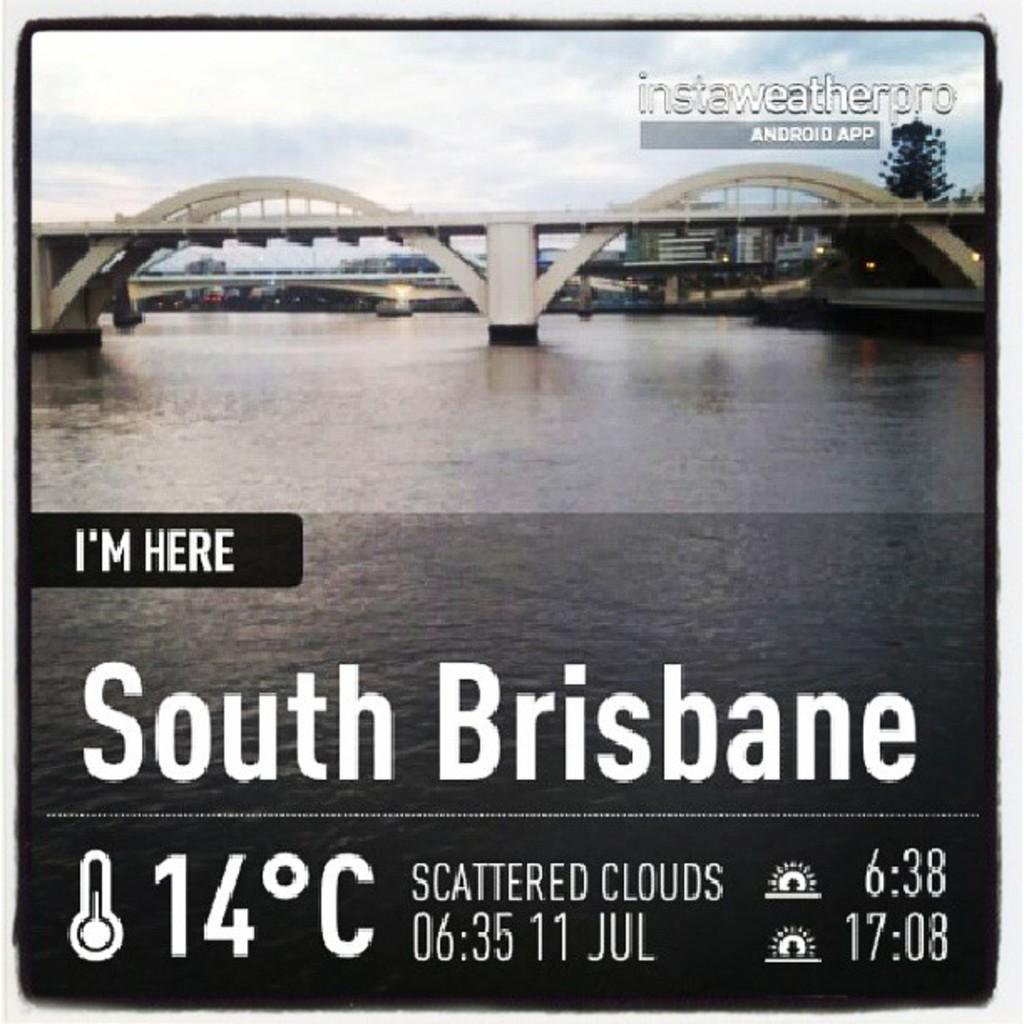<image>
Give a short and clear explanation of the subsequent image. a bridge that has the location of South Brisbane on it 